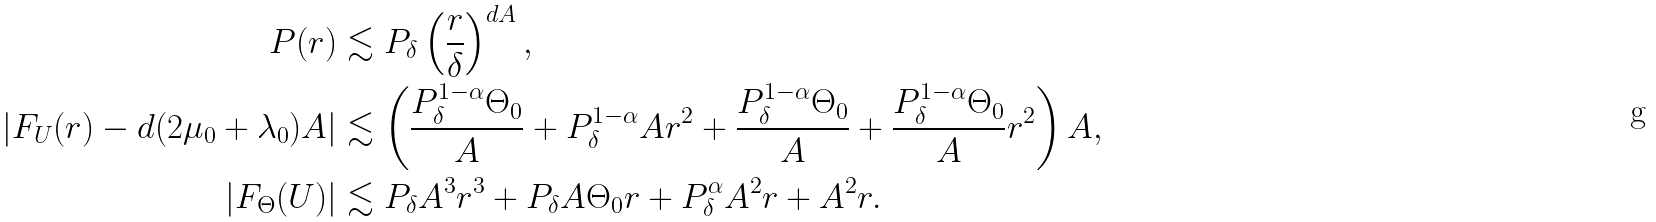Convert formula to latex. <formula><loc_0><loc_0><loc_500><loc_500>P ( r ) & \lesssim P _ { \delta } \left ( \frac { r } { \delta } \right ) ^ { d A } , \\ | F _ { U } ( r ) - d ( 2 \mu _ { 0 } + \lambda _ { 0 } ) A | & \lesssim \left ( \frac { P _ { \delta } ^ { 1 - \alpha } \Theta _ { 0 } } { A } + P _ { \delta } ^ { 1 - \alpha } A r ^ { 2 } + \frac { P _ { \delta } ^ { 1 - \alpha } \Theta _ { 0 } } { A } + \frac { P _ { \delta } ^ { 1 - \alpha } \Theta _ { 0 } } { A } r ^ { 2 } \right ) A , \\ | F _ { \Theta } ( U ) | & \lesssim P _ { \delta } A ^ { 3 } r ^ { 3 } + P _ { \delta } A \Theta _ { 0 } r + P _ { \delta } ^ { \alpha } A ^ { 2 } r + A ^ { 2 } r .</formula> 